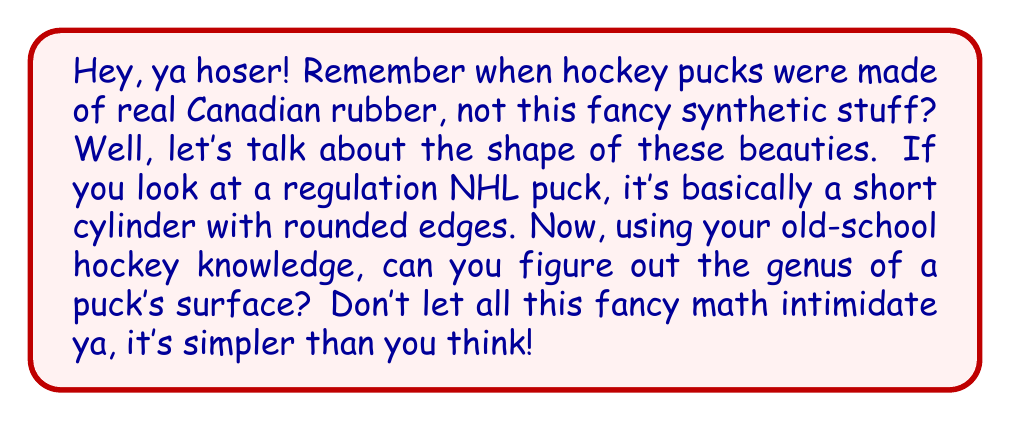Show me your answer to this math problem. Alright, let's break this down like we're analyzing a classic Gordie Howe play:

1) First off, the genus of a surface is basically the number of holes that go all the way through the object. It's like counting how many doughnut holes you can make in the surface without breaking it apart.

2) Now, picture that puck in your mind. It's got two flat circular faces (top and bottom) and a curved side surface connecting them. The key is to realize that this shape can be continuously deformed into a sphere without tearing or gluing.

3) Here's how you can imagine it:
   - Start by pushing the center of one circular face towards the other.
   - As you keep pushing, the puck will start to look more like a bowl.
   - Keep going until the edges of the two circular faces meet.
   - What you end up with is essentially a sphere (with a bit of a bulge, but topologically equivalent).

4) In topology, we care about the fundamental shape, not the exact dimensions. So our puck is equivalent to a sphere.

5) Now, the important bit: a sphere has no holes going all the way through it.

6) In mathematical terms, we express the genus of a sphere as:

   $$g = 0$$

   Where $g$ represents the genus.

So, just like how there were no holes in old-time hockey (because real players didn't need 'em), there are no holes in our puck!
Answer: The genus of a hockey puck's surface is 0. 